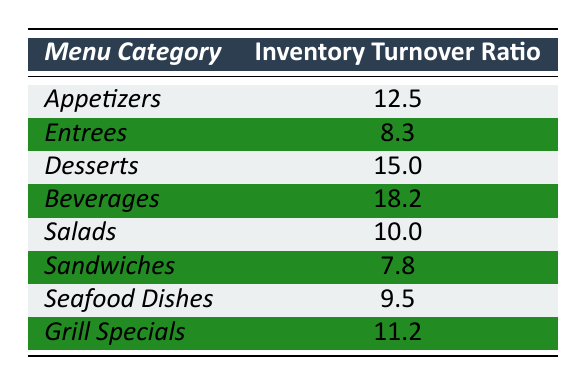What is the inventory turnover ratio for Desserts? The table shows the inventory turnover ratio for Desserts is listed directly under the Desserts category. The value provided is 15.0.
Answer: 15.0 Which menu category has the highest inventory turnover ratio? By evaluating the ratios in the table, we see that Beverages has the highest value at 18.2 among all the menu categories.
Answer: Beverages What is the inventory turnover ratio for Sandwiches? The table states the inventory turnover ratio for Sandwiches, which is specifically noted as 7.8.
Answer: 7.8 What is the difference in inventory turnover ratios between Desserts and Appetizers? From the table, Desserts has an inventory turnover ratio of 15.0 and Appetizers has a ratio of 12.5. The difference is calculated by subtracting 12.5 from 15.0, which equals 2.5.
Answer: 2.5 What is the average inventory turnover ratio for all menu categories combined? To find the average, sum all the ratios (12.5 + 8.3 + 15.0 + 18.2 + 10.0 + 7.8 + 9.5 + 11.2) which equals 92.5. There are 8 categories, so divide 92.5 by 8 to get the average: 92.5 / 8 = 11.5625.
Answer: 11.56 Are there any menu categories with an inventory turnover ratio below 10? By checking the table, we can see that the categories Entrees (8.3), Sandwiches (7.8), and Seafood Dishes (9.5) all have ratios below 10. Since there are categories below this threshold, the answer is yes.
Answer: Yes How many menu categories have an inventory turnover ratio above 10? Looking at the table, the categories with ratios above 10 are Appetizers (12.5), Desserts (15.0), Beverages (18.2), Grill Specials (11.2), making it a total of 4 categories.
Answer: 4 Which menu categories fall below the average inventory turnover ratio? The average ratio calculated earlier is approximately 11.56. The categories below this average are Entrees (8.3), Sandwiches (7.8), and Seafood Dishes (9.5), which totals to 3 categories.
Answer: 3 